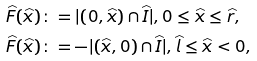Convert formula to latex. <formula><loc_0><loc_0><loc_500><loc_500>\widehat { F } ( \widehat { x } ) & \colon = | ( 0 , \widehat { x } ) \cap \widehat { I } | , 0 \leq \widehat { x } \leq \widehat { r } , \\ \widehat { F } ( \widehat { x } ) & \colon = - | ( \widehat { x } , 0 ) \cap \widehat { I } | , \widehat { l } \leq \widehat { x } < 0 ,</formula> 